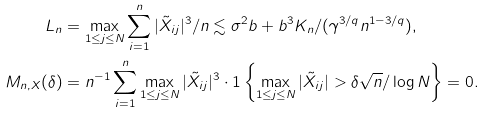Convert formula to latex. <formula><loc_0><loc_0><loc_500><loc_500>L _ { n } & = \max _ { 1 \leq j \leq N } \sum _ { i = 1 } ^ { n } | \tilde { X } _ { i j } | ^ { 3 } / n \lesssim \sigma ^ { 2 } b + b ^ { 3 } K _ { n } / ( \gamma ^ { 3 / q } n ^ { 1 - 3 / q } ) , \\ M _ { n , X } ( \delta ) & = n ^ { - 1 } \sum _ { i = 1 } ^ { n } \max _ { 1 \leq j \leq N } | \tilde { X } _ { i j } | ^ { 3 } \cdot 1 \left \{ \max _ { 1 \leq j \leq N } | \tilde { X } _ { i j } | > \delta \sqrt { n } / \log N \right \} = 0 .</formula> 